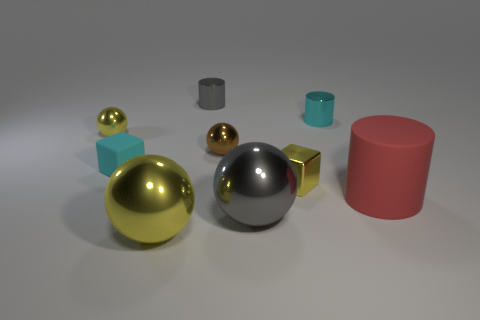There is a cyan metal object that is the same shape as the red thing; what is its size?
Your response must be concise. Small. What size is the thing that is in front of the red rubber cylinder and on the left side of the brown object?
Offer a terse response. Large. Are there any tiny yellow metallic objects right of the large yellow metallic object?
Your response must be concise. Yes. What number of objects are either small objects that are behind the cyan rubber cube or yellow rubber spheres?
Make the answer very short. 4. There is a gray object behind the large red thing; how many yellow objects are left of it?
Make the answer very short. 2. Is the number of yellow metallic blocks to the left of the tiny matte thing less than the number of tiny gray cylinders that are in front of the small yellow sphere?
Make the answer very short. No. What is the shape of the gray metallic thing behind the cyan rubber cube that is behind the gray metal ball?
Make the answer very short. Cylinder. What number of other objects are there of the same material as the tiny cyan cube?
Your answer should be very brief. 1. Are there any other things that have the same size as the yellow metal cube?
Your answer should be very brief. Yes. Is the number of tiny yellow metallic balls greater than the number of yellow metallic objects?
Offer a very short reply. No. 